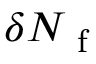<formula> <loc_0><loc_0><loc_500><loc_500>\delta N _ { f }</formula> 